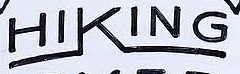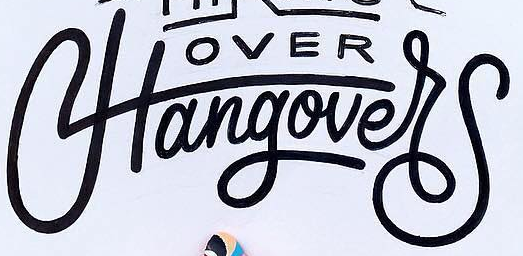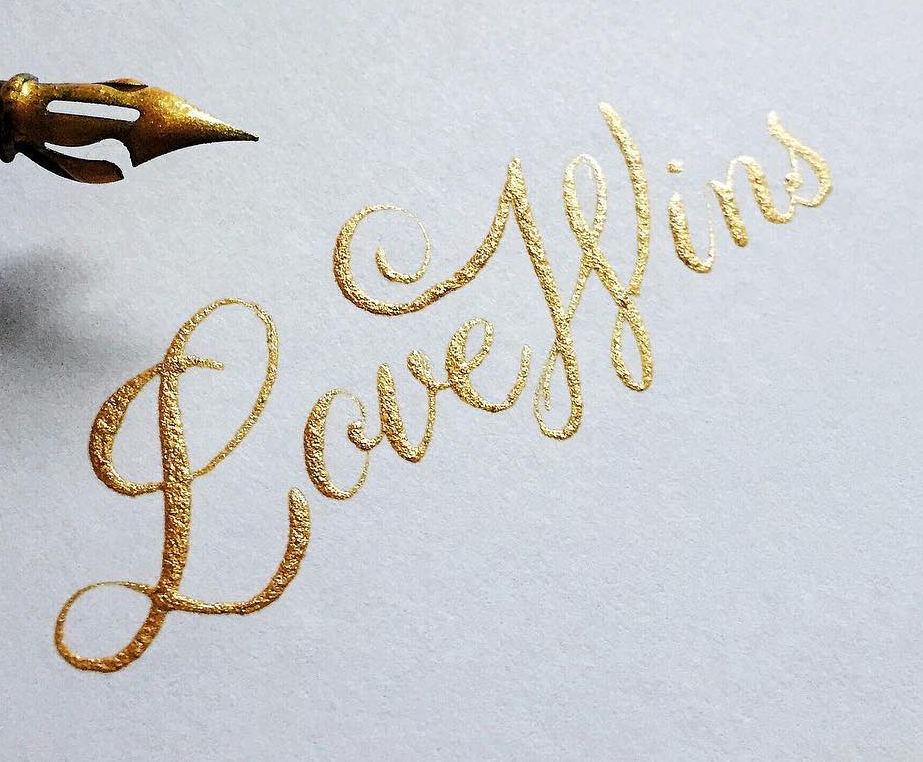Identify the words shown in these images in order, separated by a semicolon. HIKING; Hangover; LoveWins 